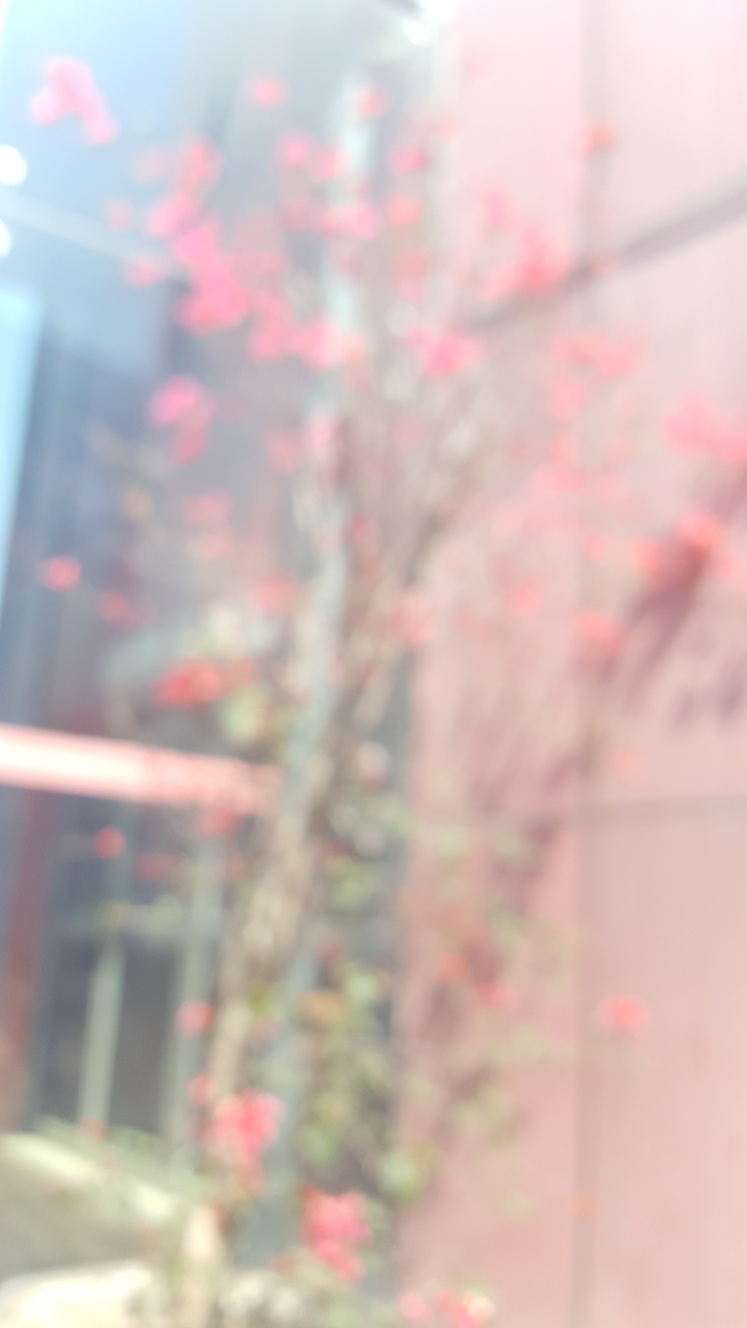What kind of tree is depicted in this image, and can you tell me more about it? The tree in the image appears to be a cherry blossom tree, often known as 'sakura' in Japan. These trees are famous for their beautiful, ephemeral blossoms, which typically bloom in spring and are celebrated worldwide for their beauty and symbolism of renewal. Why might this specific tree be significant in a cultural context? Cherry blossoms hold profound significance in many cultures, particularly in Japan where they symbolize the transient nature of life. This time of bloom corresponds to many festivals and gatherings where people celebrate the season by having outdoor picnics under the flowering trees. The blossoms also inspire various forms of art and poetry, embodying themes of beauty, awakening, and the inevitable passage of time. 